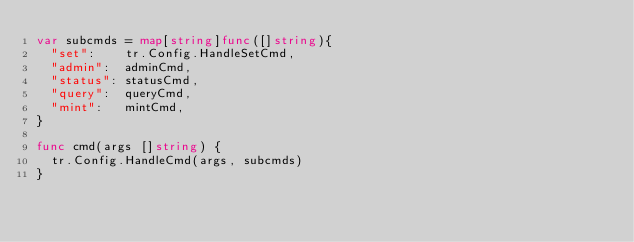<code> <loc_0><loc_0><loc_500><loc_500><_Go_>var subcmds = map[string]func([]string){
	"set":    tr.Config.HandleSetCmd,
	"admin":  adminCmd,
	"status": statusCmd,
	"query":  queryCmd,
	"mint":   mintCmd,
}

func cmd(args []string) {
	tr.Config.HandleCmd(args, subcmds)
}
</code> 